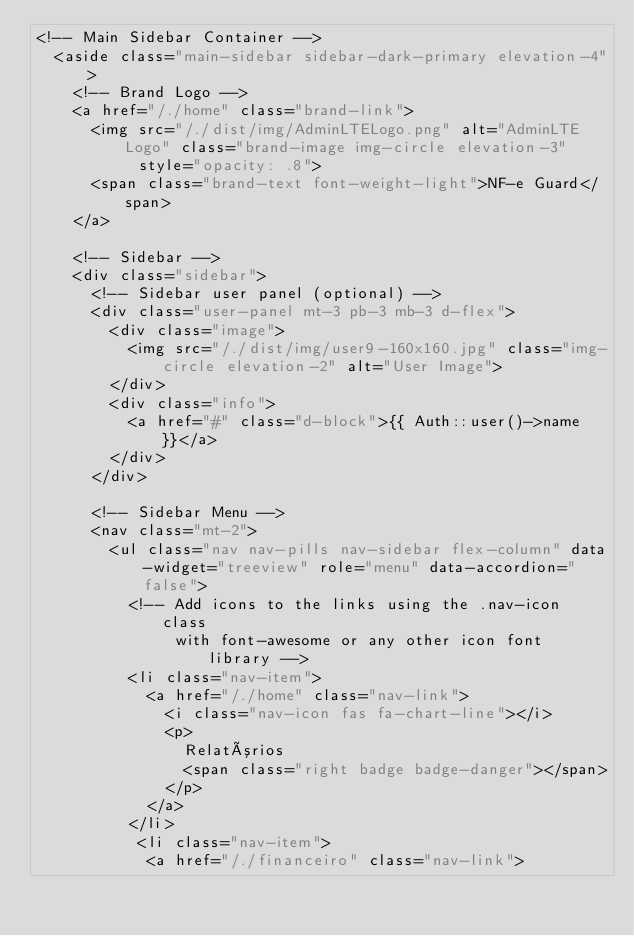Convert code to text. <code><loc_0><loc_0><loc_500><loc_500><_PHP_><!-- Main Sidebar Container -->
  <aside class="main-sidebar sidebar-dark-primary elevation-4">
    <!-- Brand Logo -->
    <a href="/./home" class="brand-link">
      <img src="/./dist/img/AdminLTELogo.png" alt="AdminLTE Logo" class="brand-image img-circle elevation-3"
           style="opacity: .8">
      <span class="brand-text font-weight-light">NF-e Guard</span>
    </a>

    <!-- Sidebar -->
    <div class="sidebar">
      <!-- Sidebar user panel (optional) -->
      <div class="user-panel mt-3 pb-3 mb-3 d-flex">
        <div class="image">
          <img src="/./dist/img/user9-160x160.jpg" class="img-circle elevation-2" alt="User Image">
        </div>
        <div class="info">
          <a href="#" class="d-block">{{ Auth::user()->name }}</a>
        </div>
      </div>

      <!-- Sidebar Menu -->
      <nav class="mt-2">
        <ul class="nav nav-pills nav-sidebar flex-column" data-widget="treeview" role="menu" data-accordion="false">
          <!-- Add icons to the links using the .nav-icon class
               with font-awesome or any other icon font library -->
          <li class="nav-item">
            <a href="/./home" class="nav-link">
              <i class="nav-icon fas fa-chart-line"></i>
              <p>
                Relatórios
                <span class="right badge badge-danger"></span>
              </p>
            </a>
          </li>
           <li class="nav-item">
            <a href="/./financeiro" class="nav-link"></code> 